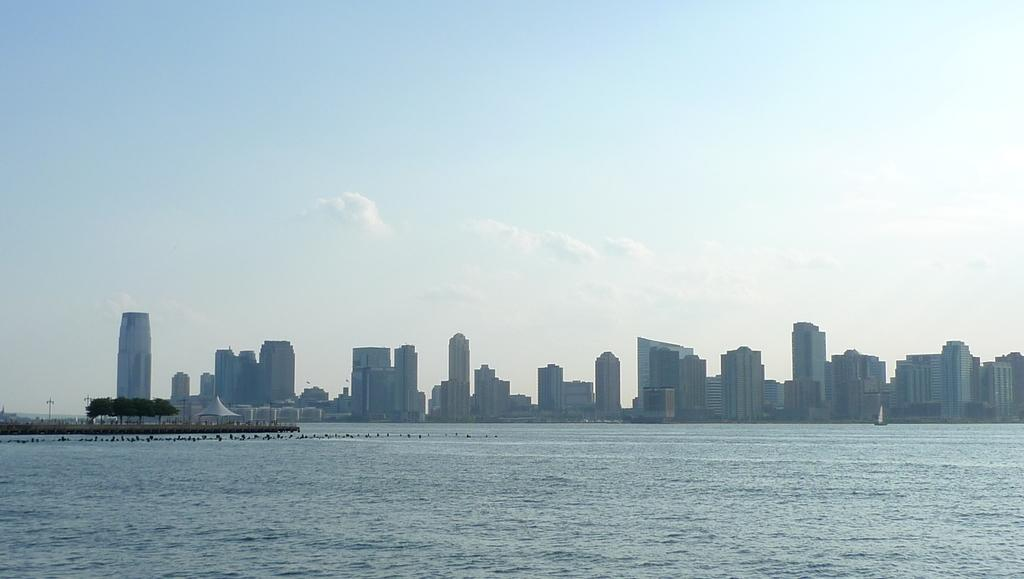What type of structures can be seen in the image? There are buildings in the image. What type of vegetation is present in the image? There are trees in the image. What type of temporary shelter is visible in the image? There is a tent in the image. What type of vehicle is present in the image? There is a boat in the image. What natural element is visible in the image? There is water visible in the image. What part of the natural environment is visible in the image? There is sky visible in the image. What can be seen in the sky? There are clouds in the sky. What type of pies can be seen in the image? There are no pies present in the image. How many cars are visible in the image? There are no cars visible in the image. 